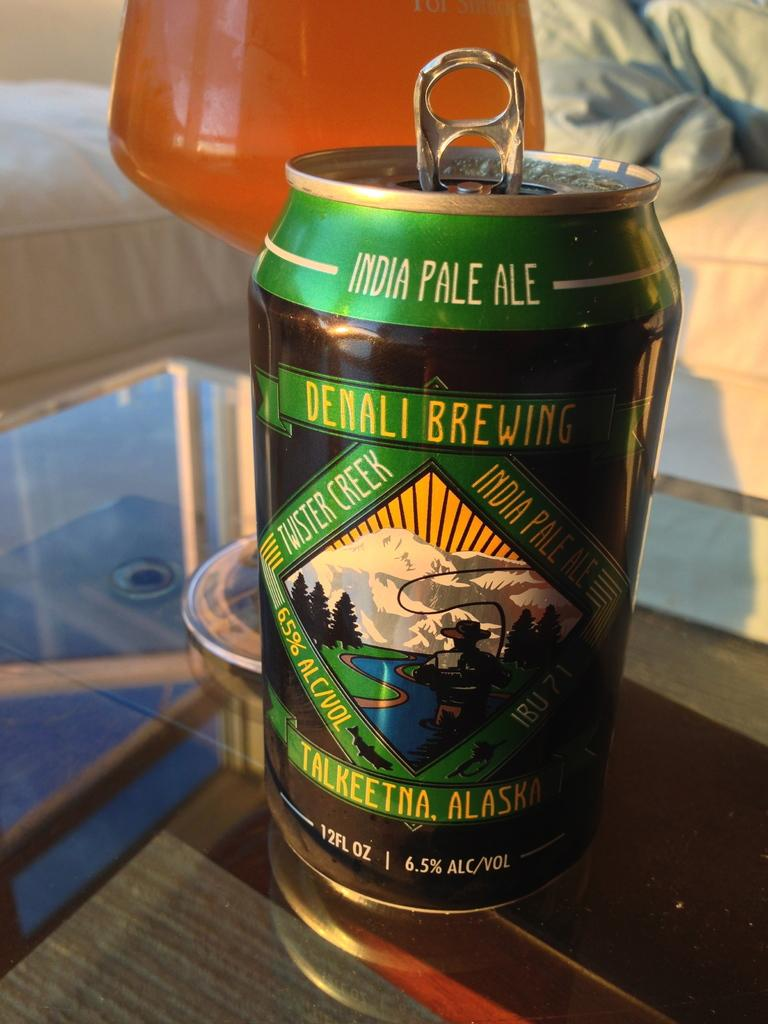<image>
Create a compact narrative representing the image presented. A can of India Pale Ale placed on top of a glass table. 